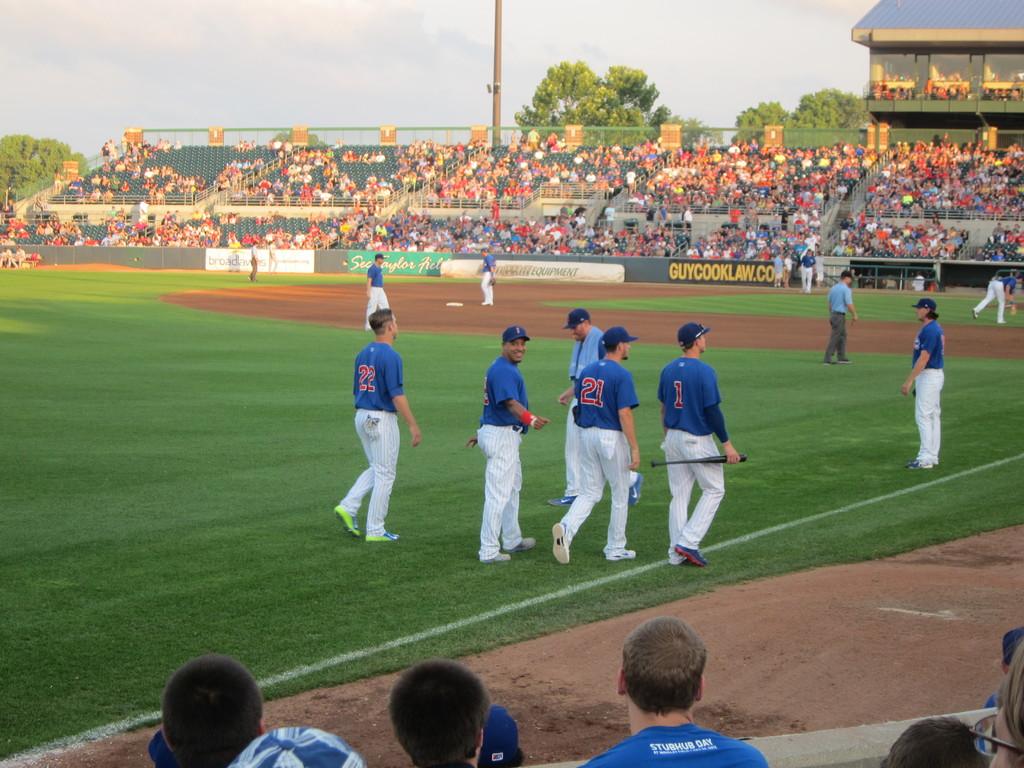What advertisement is on the wall?
Your answer should be very brief. Guycooklaw.com. What is the player to the left's number?
Offer a terse response. 22. 